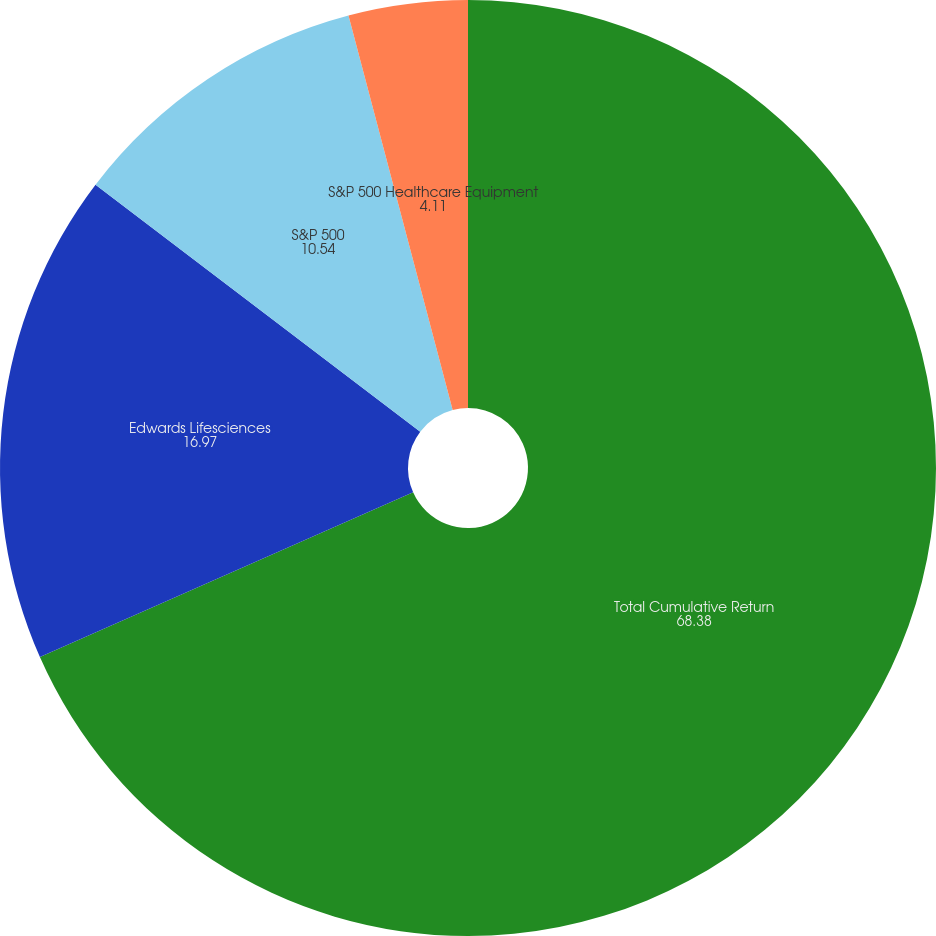<chart> <loc_0><loc_0><loc_500><loc_500><pie_chart><fcel>Total Cumulative Return<fcel>Edwards Lifesciences<fcel>S&P 500<fcel>S&P 500 Healthcare Equipment<nl><fcel>68.38%<fcel>16.97%<fcel>10.54%<fcel>4.11%<nl></chart> 